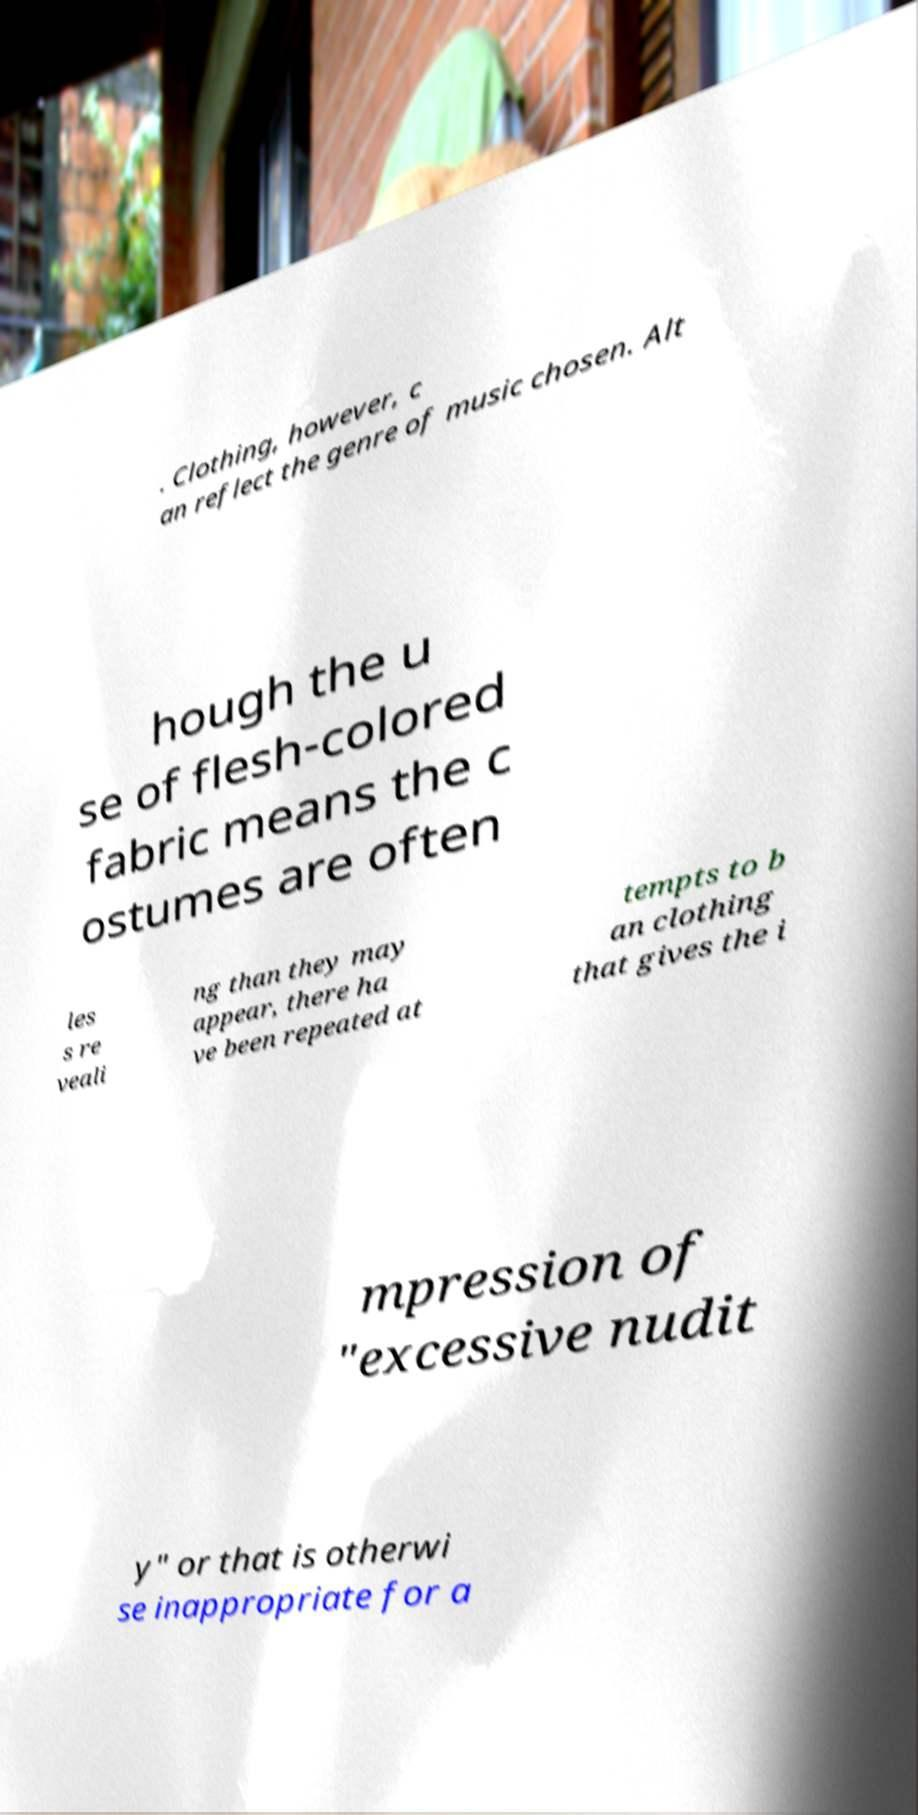Please identify and transcribe the text found in this image. . Clothing, however, c an reflect the genre of music chosen. Alt hough the u se of flesh-colored fabric means the c ostumes are often les s re veali ng than they may appear, there ha ve been repeated at tempts to b an clothing that gives the i mpression of "excessive nudit y" or that is otherwi se inappropriate for a 